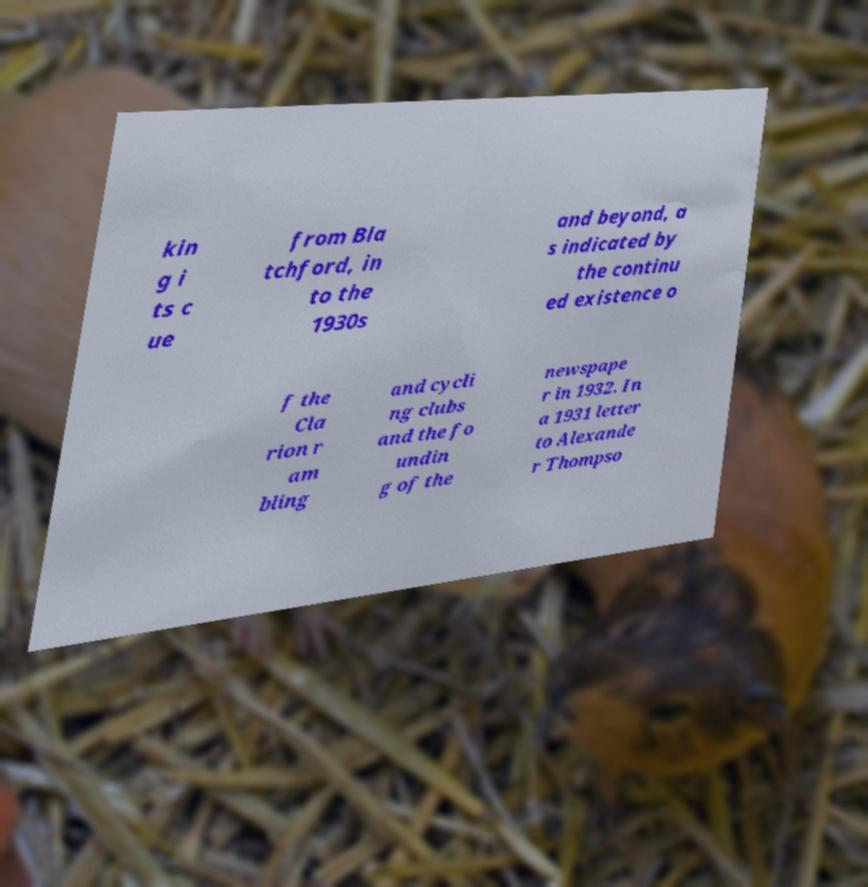For documentation purposes, I need the text within this image transcribed. Could you provide that? kin g i ts c ue from Bla tchford, in to the 1930s and beyond, a s indicated by the continu ed existence o f the Cla rion r am bling and cycli ng clubs and the fo undin g of the newspape r in 1932. In a 1931 letter to Alexande r Thompso 